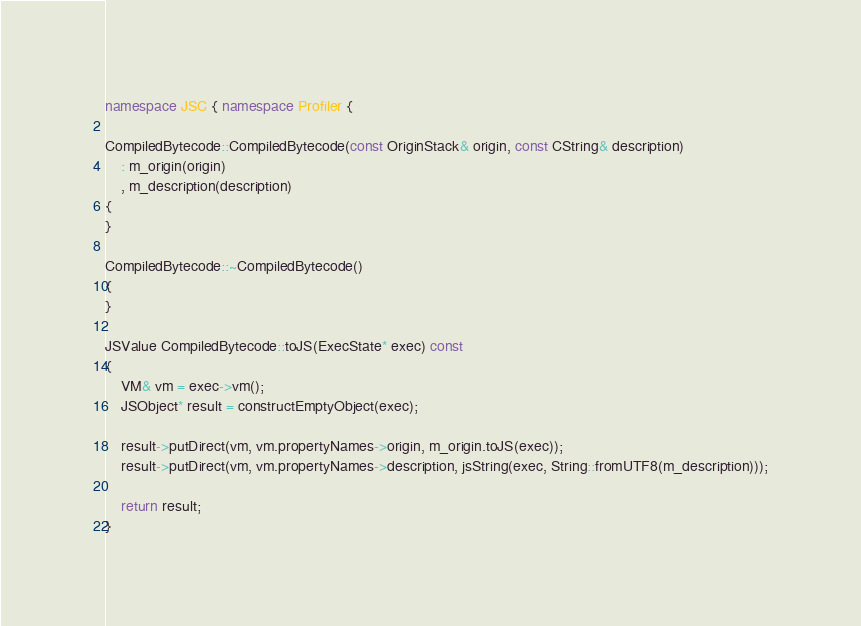Convert code to text. <code><loc_0><loc_0><loc_500><loc_500><_C++_>namespace JSC { namespace Profiler {

CompiledBytecode::CompiledBytecode(const OriginStack& origin, const CString& description)
    : m_origin(origin)
    , m_description(description)
{
}

CompiledBytecode::~CompiledBytecode()
{
}

JSValue CompiledBytecode::toJS(ExecState* exec) const
{
    VM& vm = exec->vm();
    JSObject* result = constructEmptyObject(exec);
    
    result->putDirect(vm, vm.propertyNames->origin, m_origin.toJS(exec));
    result->putDirect(vm, vm.propertyNames->description, jsString(exec, String::fromUTF8(m_description)));
    
    return result;
}
</code> 